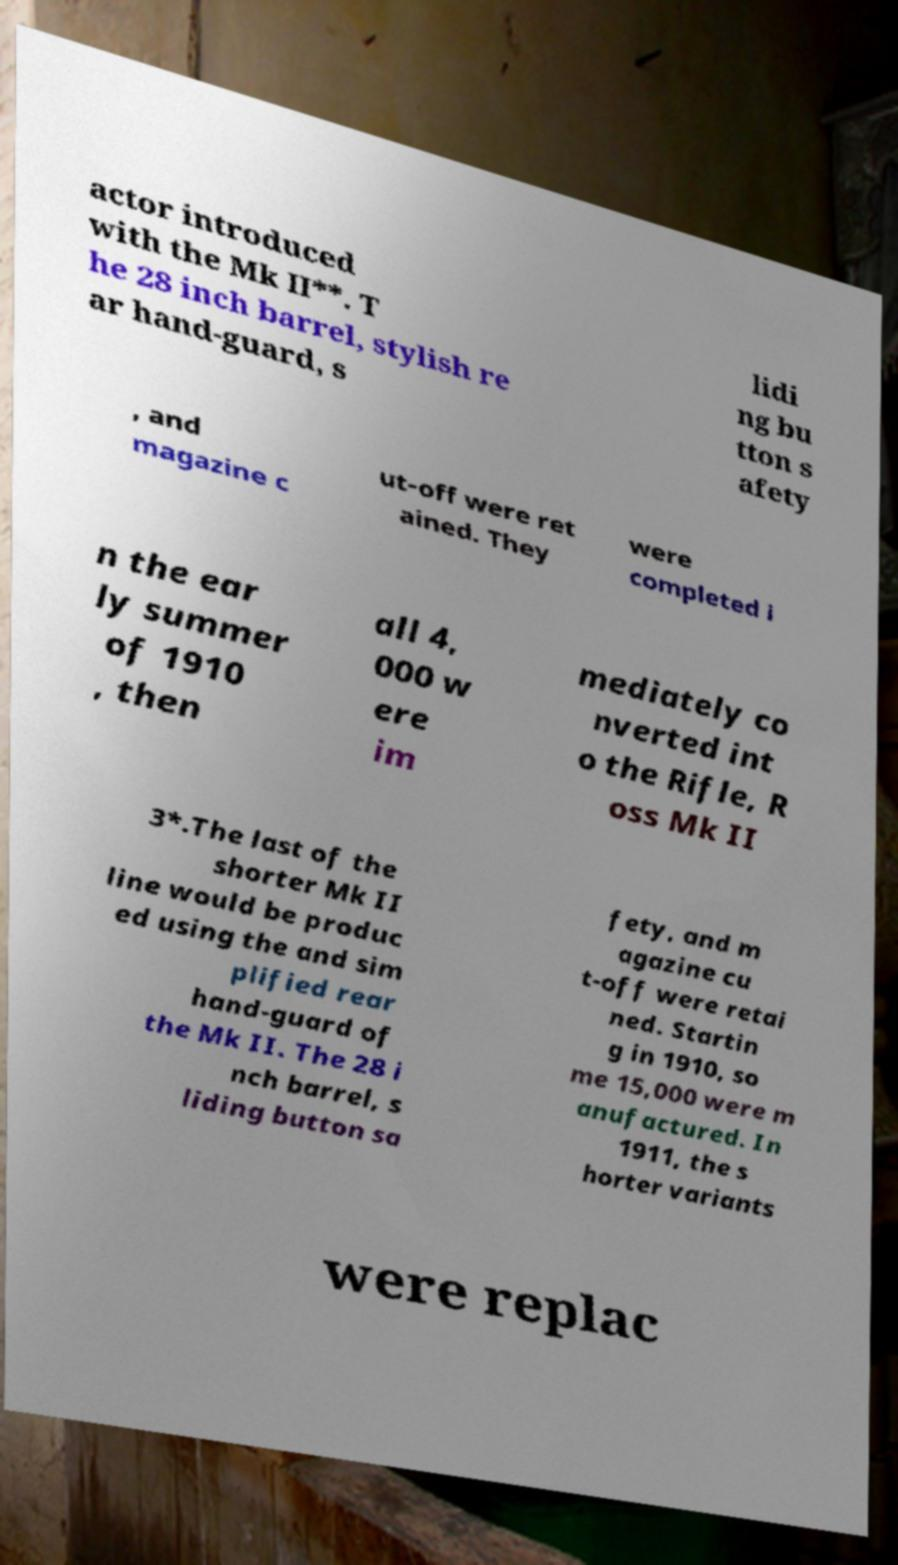For documentation purposes, I need the text within this image transcribed. Could you provide that? actor introduced with the Mk II**. T he 28 inch barrel, stylish re ar hand-guard, s lidi ng bu tton s afety , and magazine c ut-off were ret ained. They were completed i n the ear ly summer of 1910 , then all 4, 000 w ere im mediately co nverted int o the Rifle, R oss Mk II 3*.The last of the shorter Mk II line would be produc ed using the and sim plified rear hand-guard of the Mk II. The 28 i nch barrel, s liding button sa fety, and m agazine cu t-off were retai ned. Startin g in 1910, so me 15,000 were m anufactured. In 1911, the s horter variants were replac 